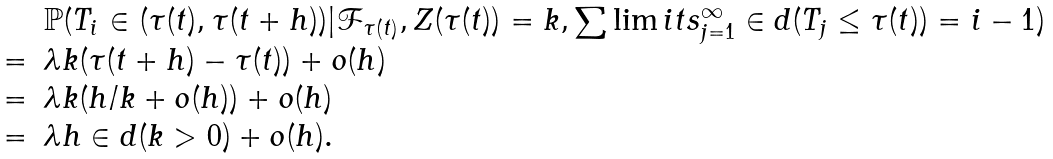Convert formula to latex. <formula><loc_0><loc_0><loc_500><loc_500>\begin{array} { r l } \ & \mathbb { P } ( T _ { i } \in ( \tau ( t ) , \tau ( t + h ) ) | \mathcal { F } _ { \tau ( t ) } , Z ( \tau ( t ) ) = k , \sum \lim i t s _ { j = 1 } ^ { \infty } \in d ( T _ { j } \leq \tau ( t ) ) = i - 1 ) \\ = & \lambda k ( \tau ( t + h ) - \tau ( t ) ) + o ( h ) \\ = & \lambda k ( h / k + o ( h ) ) + o ( h ) \\ = & \lambda h \in d ( k > 0 ) + o ( h ) . \\ \end{array}</formula> 